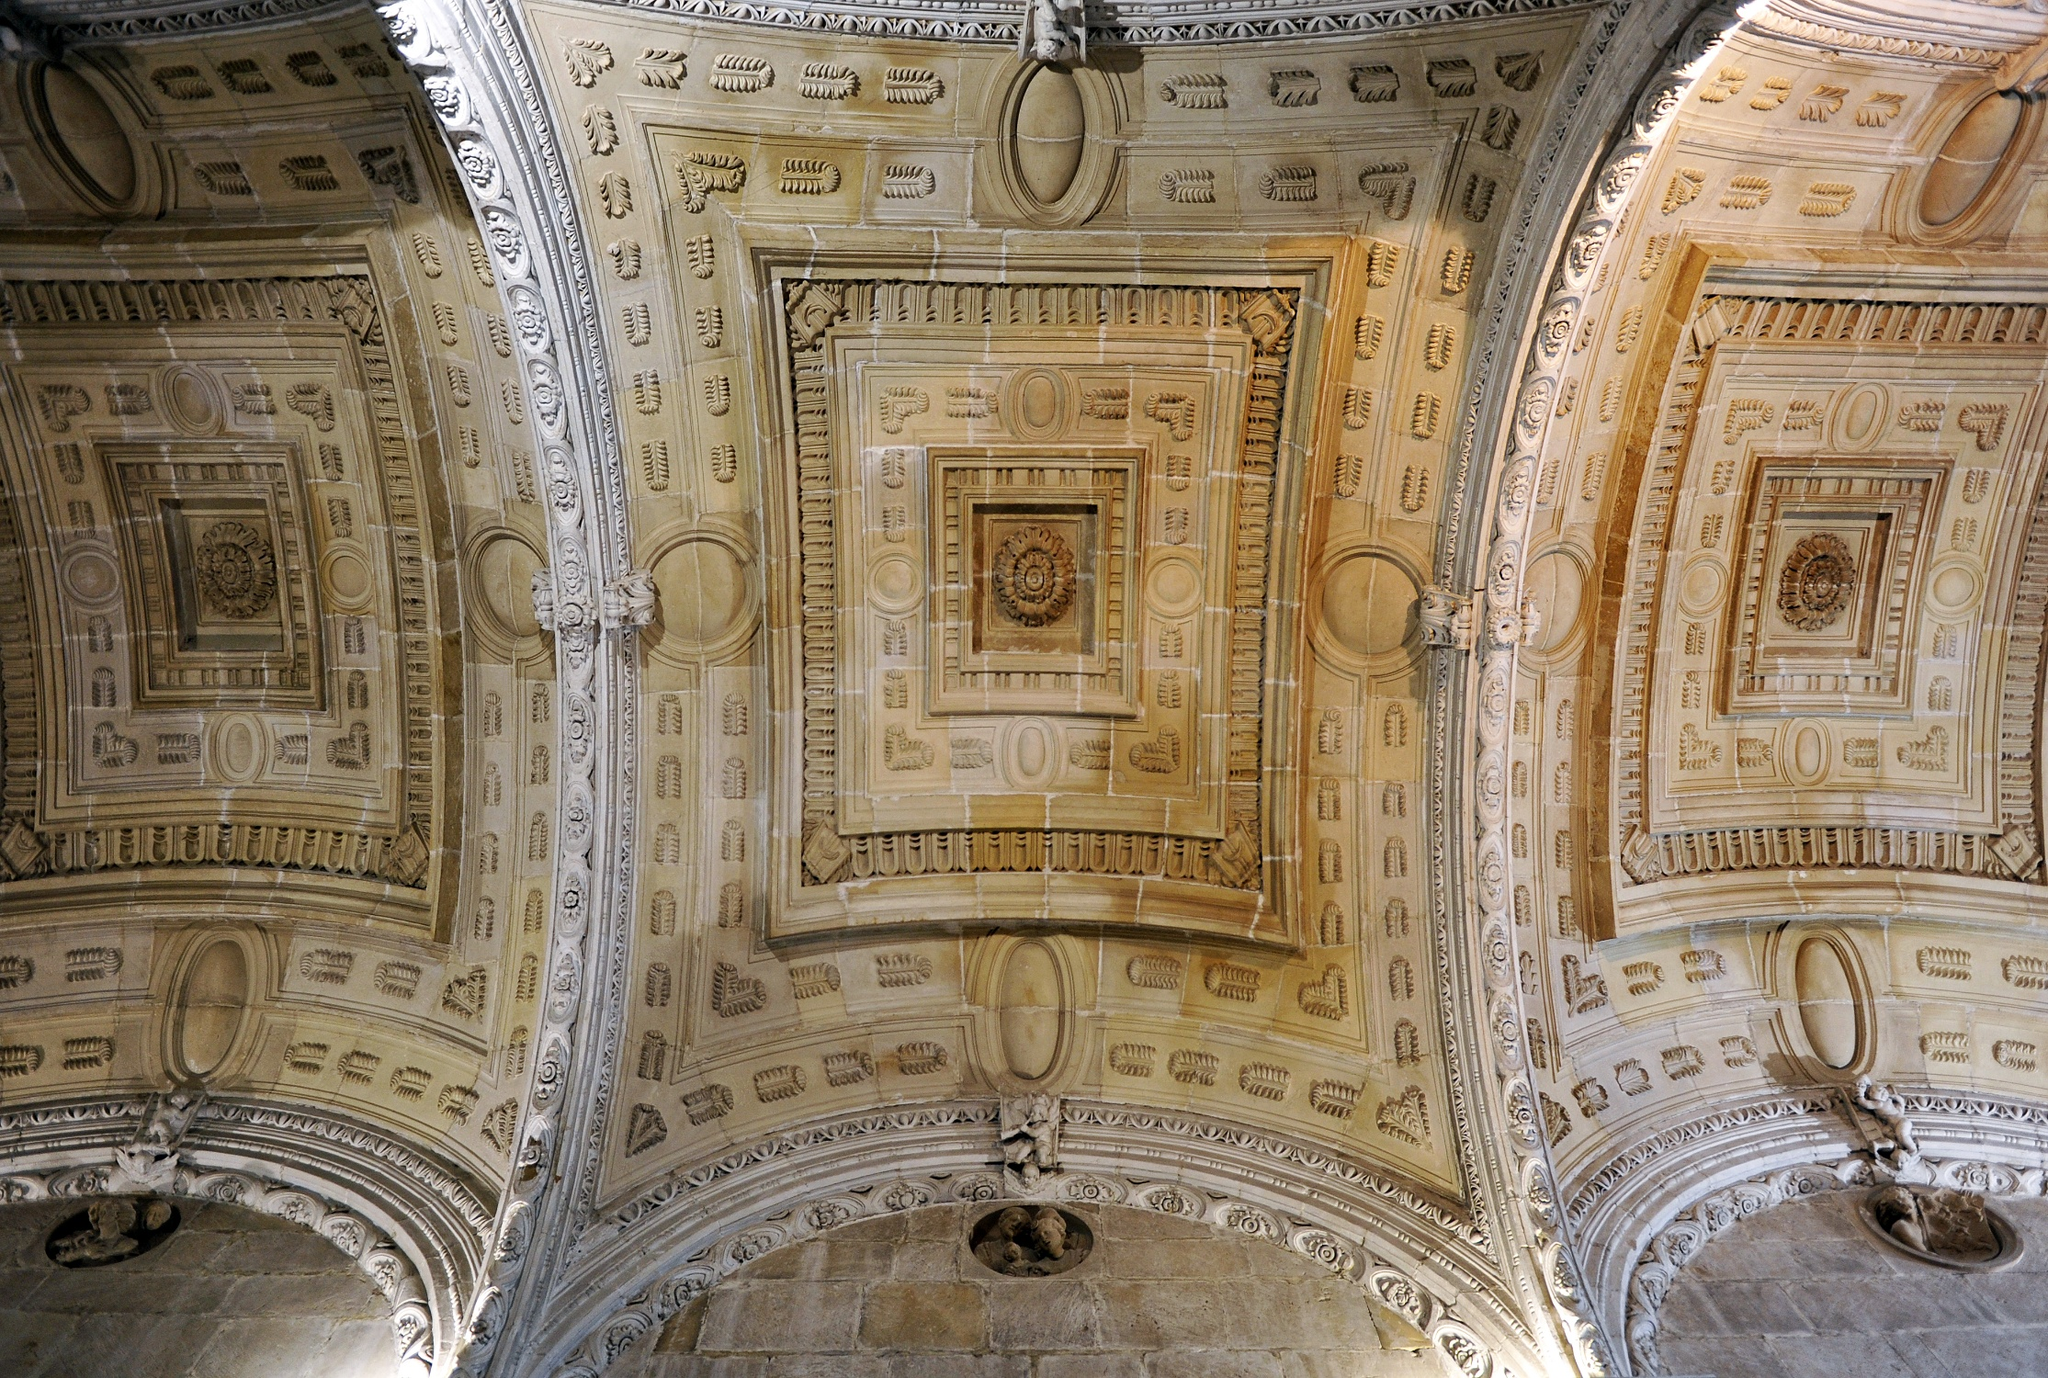Imagine if the ceiling could speak. What stories would it tell? If the ceiling could speak, it would narrate tales of the centuries it has silently observed. It would tell of the craftsmen who, with painstaking detail, brought it to life, their voices mingling in the air as they worked tirelessly. It would recount the grand festivities that filled the hall beneath, where the laughter of guests resonated, and the melodies of age-old instruments created a symphony of joy. The ceiling would whisper secrets of clandestine meetings held in hushed tones during times of political strife, decisions that altered the course of history made under its watchful eye. It would share moments of quiet reflection as individuals sought solace within the grandeur of the hall. The ceiling would embody the essence of time itself, a silent chronicler of human endeavor and emotion, forever intertwined with the legacy of those it sheltered. 